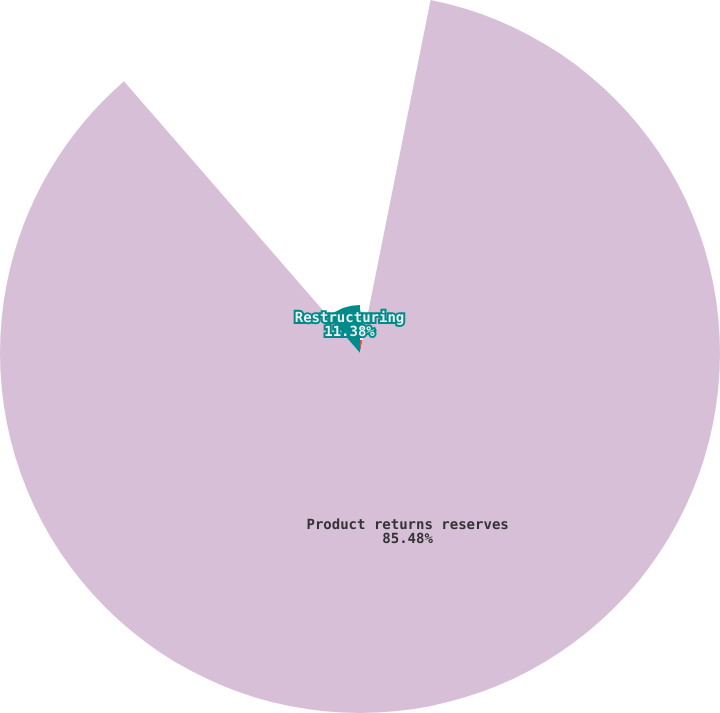Convert chart to OTSL. <chart><loc_0><loc_0><loc_500><loc_500><pie_chart><fcel>Allowance for doubtful<fcel>Product returns reserves<fcel>Restructuring<nl><fcel>3.14%<fcel>85.48%<fcel>11.38%<nl></chart> 